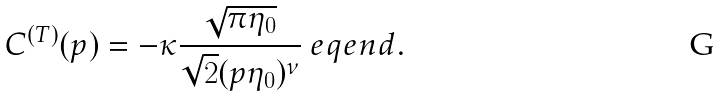Convert formula to latex. <formula><loc_0><loc_0><loc_500><loc_500>C ^ { ( T ) } ( p ) = - \kappa \frac { \sqrt { \pi \eta _ { 0 } } } { \sqrt { 2 } ( p \eta _ { 0 } ) ^ { \nu } } \ e q e n d { . }</formula> 